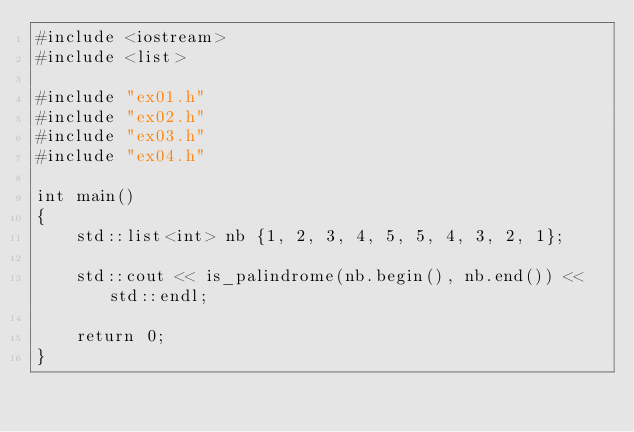Convert code to text. <code><loc_0><loc_0><loc_500><loc_500><_C++_>#include <iostream>
#include <list>

#include "ex01.h"
#include "ex02.h"
#include "ex03.h"
#include "ex04.h"

int main()
{
    std::list<int> nb {1, 2, 3, 4, 5, 5, 4, 3, 2, 1};

    std::cout << is_palindrome(nb.begin(), nb.end()) << std::endl;

    return 0;
}
</code> 